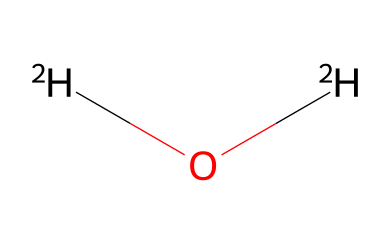What is the common name for [2H]O[2H]? The chemical structure [2H]O[2H] represents deuterium oxide, commonly known as heavy water. The "2H" indicates the presence of deuterium, a stable isotope of hydrogen.
Answer: heavy water How many hydrogen atoms are in this molecule? The structure [2H]O[2H] contains two deuterium atoms (which are hydrogen isotopes), and they are reflected in the notation.
Answer: 2 What type of hydrogen is present in this chemical? The chemical contains deuterium, which is an isotope of hydrogen with one neutron, as indicated by the "[2H]" notation.
Answer: deuterium How does deuterium oxide differ from regular water? Deuterium oxide has deuterium instead of the regular hydrogen found in water (H2O), which gives it different physical properties, like higher density.
Answer: higher density What is the significance of deuterium oxide in NMR spectroscopy? Deuterium oxide is used as a solvent in NMR spectroscopy because it does not produce a signal in the proton NMR spectrum, allowing better observation of the solute.
Answer: no signal What distinguishes heavy water from ordinary water in terms of isotope composition? Heavy water is composed of deuterium (2H), whereas ordinary water is composed of protium (1H); this difference in composition leads to varying physical properties.
Answer: isotope composition 